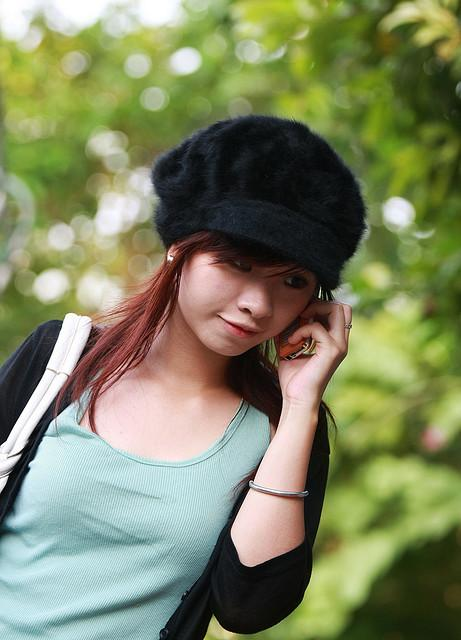Who speaks at this moment? caller 